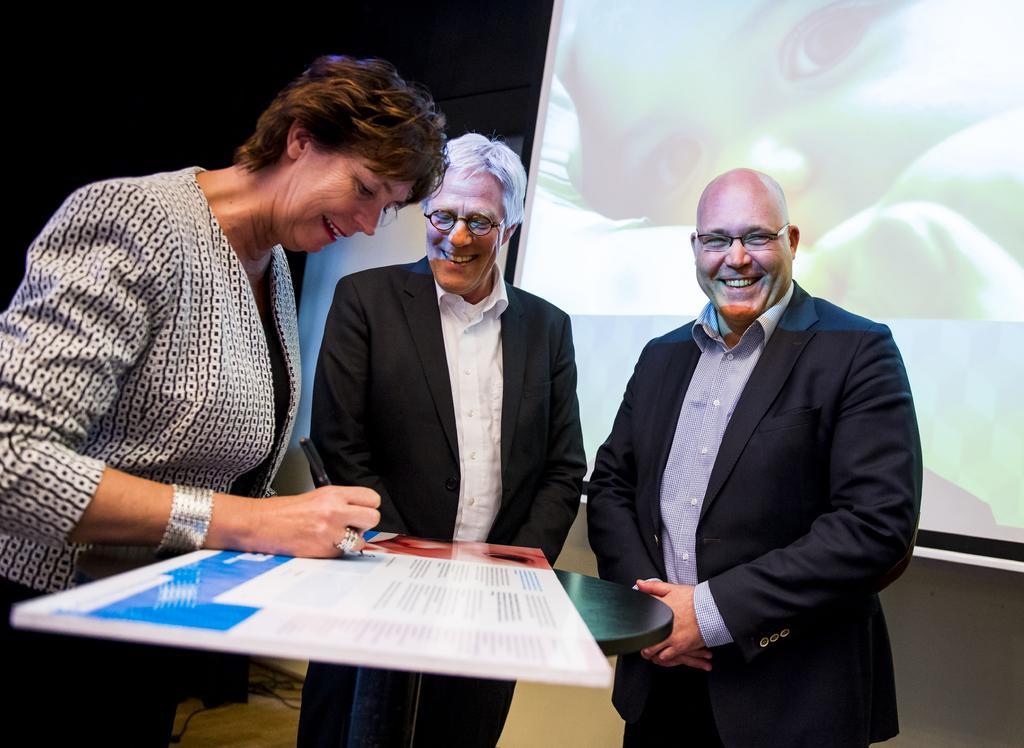Please provide a concise description of this image. This picture describes about few people, they are standing and smiling, in the left side of the given image we can see a woman, she is writing, in the background we can see a projector screen. 